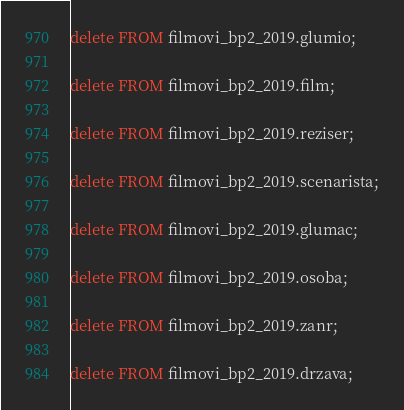<code> <loc_0><loc_0><loc_500><loc_500><_SQL_>delete FROM filmovi_bp2_2019.glumio;

delete FROM filmovi_bp2_2019.film;

delete FROM filmovi_bp2_2019.reziser;

delete FROM filmovi_bp2_2019.scenarista;

delete FROM filmovi_bp2_2019.glumac;

delete FROM filmovi_bp2_2019.osoba;

delete FROM filmovi_bp2_2019.zanr;

delete FROM filmovi_bp2_2019.drzava;

</code> 